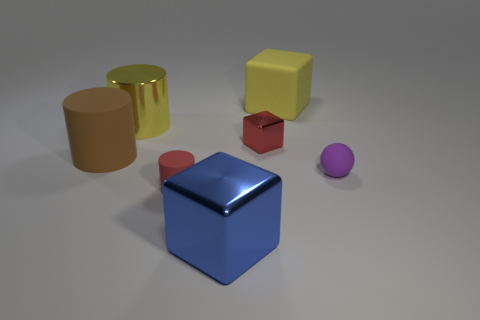There is another tiny matte object that is the same shape as the brown object; what color is it?
Provide a succinct answer. Red. Are there any other things that have the same shape as the tiny purple object?
Provide a succinct answer. No. There is a small metallic object; is its shape the same as the matte object behind the red block?
Your answer should be compact. Yes. How many other objects are the same material as the yellow cylinder?
Provide a short and direct response. 2. There is a large shiny cube; is it the same color as the metallic cube that is behind the brown object?
Provide a succinct answer. No. What is the material of the large object on the left side of the yellow shiny cylinder?
Provide a succinct answer. Rubber. Are there any small metallic balls of the same color as the small shiny cube?
Keep it short and to the point. No. What is the color of the cylinder that is the same size as the ball?
Your response must be concise. Red. How many small objects are either blue metal things or green rubber things?
Your answer should be very brief. 0. Are there the same number of purple rubber objects that are behind the small sphere and yellow cylinders behind the large metallic cylinder?
Give a very brief answer. Yes. 